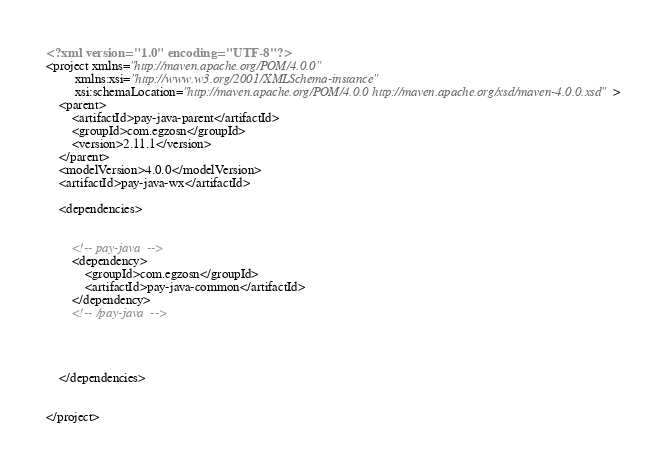<code> <loc_0><loc_0><loc_500><loc_500><_XML_><?xml version="1.0" encoding="UTF-8"?>
<project xmlns="http://maven.apache.org/POM/4.0.0"
         xmlns:xsi="http://www.w3.org/2001/XMLSchema-instance"
         xsi:schemaLocation="http://maven.apache.org/POM/4.0.0 http://maven.apache.org/xsd/maven-4.0.0.xsd">
    <parent>
        <artifactId>pay-java-parent</artifactId>
        <groupId>com.egzosn</groupId>
        <version>2.11.1</version>
    </parent>
    <modelVersion>4.0.0</modelVersion>
    <artifactId>pay-java-wx</artifactId>

    <dependencies>


        <!-- pay-java  -->
        <dependency>
            <groupId>com.egzosn</groupId>
            <artifactId>pay-java-common</artifactId>
        </dependency>
        <!-- /pay-java  -->




    </dependencies>


</project></code> 